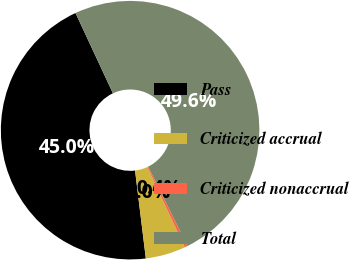<chart> <loc_0><loc_0><loc_500><loc_500><pie_chart><fcel>Pass<fcel>Criticized accrual<fcel>Criticized nonaccrual<fcel>Total<nl><fcel>45.0%<fcel>5.0%<fcel>0.37%<fcel>49.63%<nl></chart> 